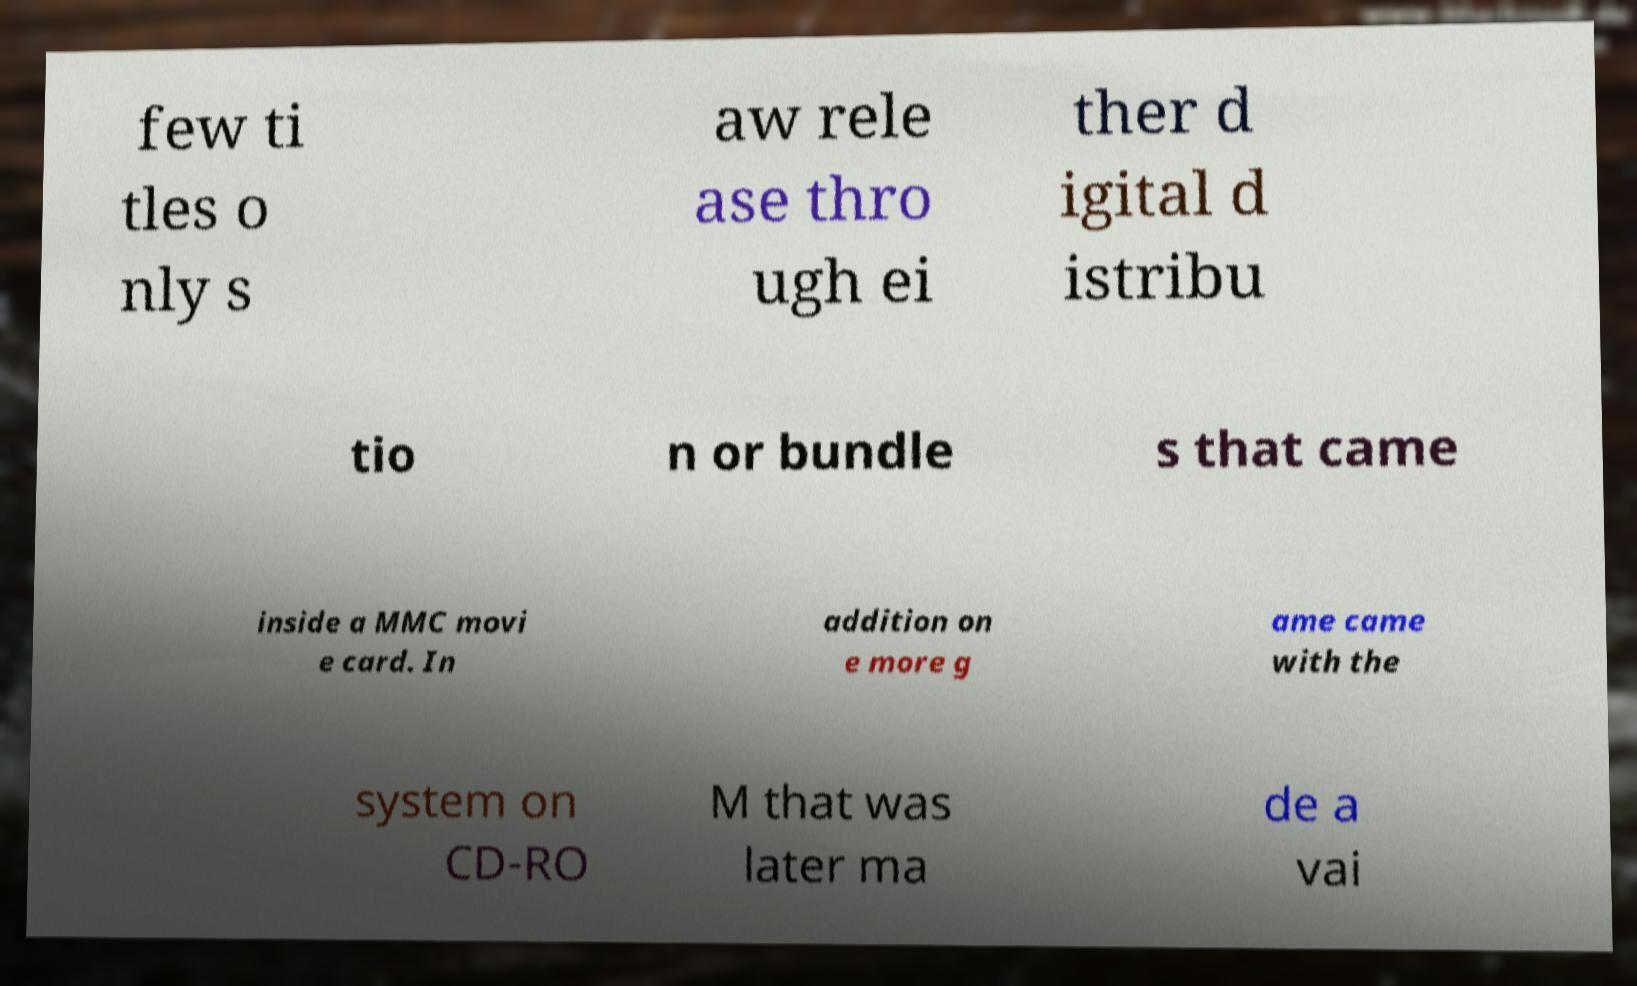For documentation purposes, I need the text within this image transcribed. Could you provide that? few ti tles o nly s aw rele ase thro ugh ei ther d igital d istribu tio n or bundle s that came inside a MMC movi e card. In addition on e more g ame came with the system on CD-RO M that was later ma de a vai 